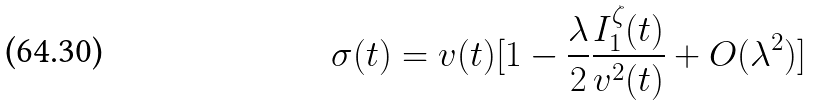Convert formula to latex. <formula><loc_0><loc_0><loc_500><loc_500>\sigma ( t ) = v ( t ) [ 1 - \frac { \lambda } { 2 } \frac { I _ { 1 } ^ { \zeta } ( t ) } { v ^ { 2 } ( t ) } + O ( \lambda ^ { 2 } ) ]</formula> 